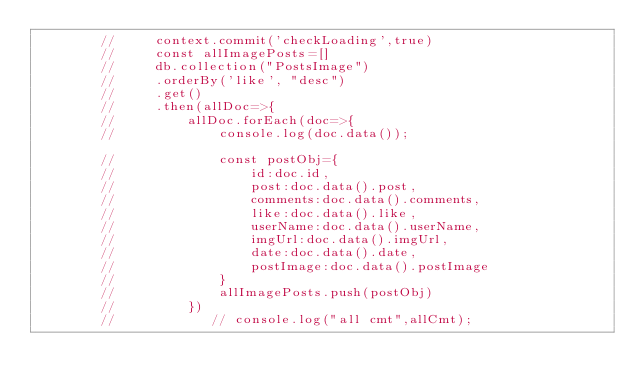Convert code to text. <code><loc_0><loc_0><loc_500><loc_500><_JavaScript_>        //     context.commit('checkLoading',true)
        //     const allImagePosts=[]
        //     db.collection("PostsImage")
        //     .orderBy('like', "desc")
        //     .get()
        //     .then(allDoc=>{
        //         allDoc.forEach(doc=>{
        //             console.log(doc.data());
                    
        //             const postObj={
        //                 id:doc.id,
        //                 post:doc.data().post,
        //                 comments:doc.data().comments,
        //                 like:doc.data().like,
        //                 userName:doc.data().userName,
        //                 imgUrl:doc.data().imgUrl,
        //                 date:doc.data().date,
        //                 postImage:doc.data().postImage
        //             }
        //             allImagePosts.push(postObj)
        //         })
        //            // console.log("all cmt",allCmt);
                    </code> 